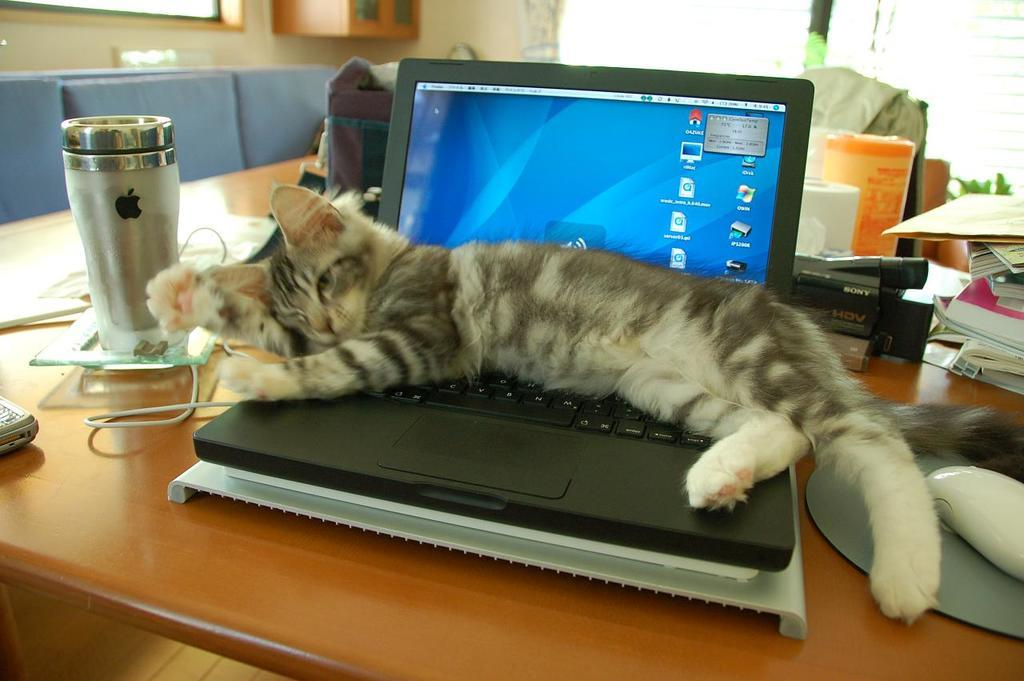What is the cat doing in the image? The cat is sitting on a laptop in the image. What else can be seen on the table besides the cat? There is a bottle, papers, and books on the table. What is visible in the background of the image? There is a cupboard and a window in the background. What type of food is the cat eating in the image? There is no food present in the image, and the cat is not shown eating anything. 